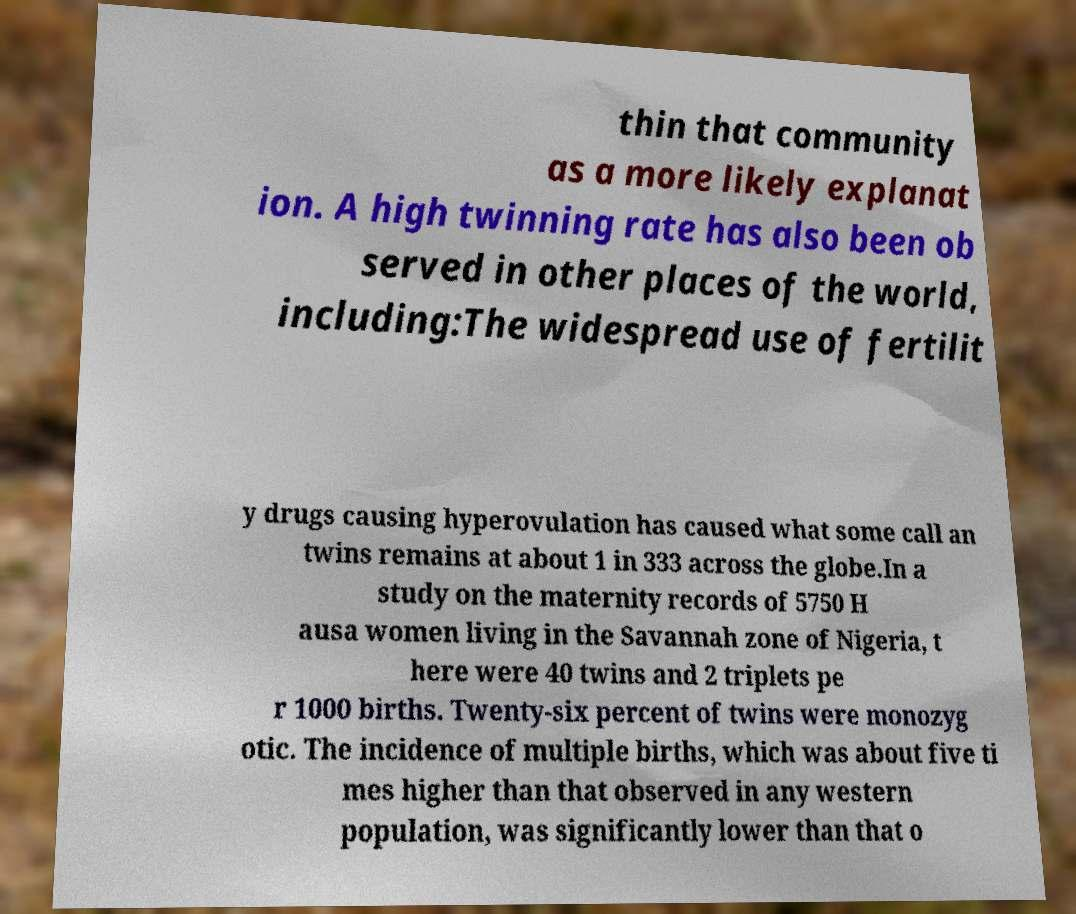Could you assist in decoding the text presented in this image and type it out clearly? thin that community as a more likely explanat ion. A high twinning rate has also been ob served in other places of the world, including:The widespread use of fertilit y drugs causing hyperovulation has caused what some call an twins remains at about 1 in 333 across the globe.In a study on the maternity records of 5750 H ausa women living in the Savannah zone of Nigeria, t here were 40 twins and 2 triplets pe r 1000 births. Twenty-six percent of twins were monozyg otic. The incidence of multiple births, which was about five ti mes higher than that observed in any western population, was significantly lower than that o 